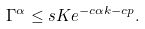<formula> <loc_0><loc_0><loc_500><loc_500>\Gamma ^ { \alpha } \leq s K e ^ { - c \alpha k - c p } .</formula> 